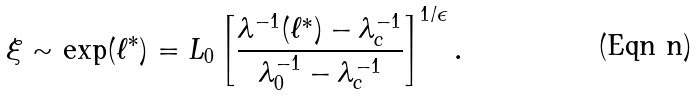<formula> <loc_0><loc_0><loc_500><loc_500>\xi \sim \exp ( \ell ^ { \ast } ) = L _ { 0 } \left [ \frac { \lambda ^ { - 1 } ( \ell ^ { \ast } ) - \lambda _ { c } ^ { - 1 } } { \lambda _ { 0 } ^ { - 1 } - \lambda _ { c } ^ { - 1 } } \right ] ^ { 1 / \epsilon } .</formula> 